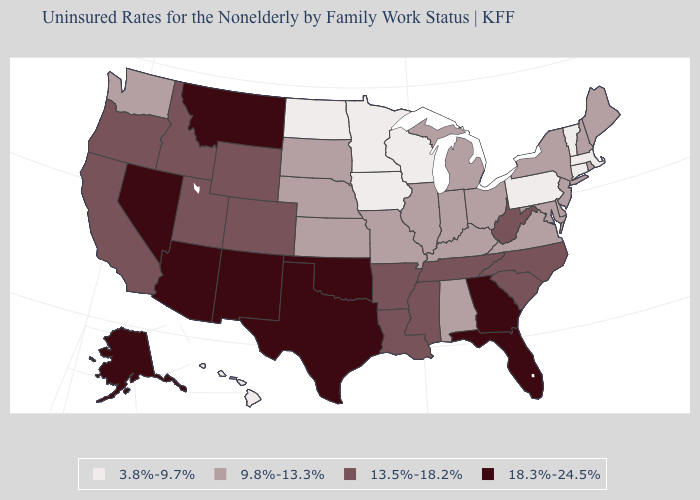Which states have the lowest value in the Northeast?
Concise answer only. Connecticut, Massachusetts, Pennsylvania, Vermont. Name the states that have a value in the range 9.8%-13.3%?
Answer briefly. Alabama, Delaware, Illinois, Indiana, Kansas, Kentucky, Maine, Maryland, Michigan, Missouri, Nebraska, New Hampshire, New Jersey, New York, Ohio, Rhode Island, South Dakota, Virginia, Washington. Name the states that have a value in the range 3.8%-9.7%?
Quick response, please. Connecticut, Hawaii, Iowa, Massachusetts, Minnesota, North Dakota, Pennsylvania, Vermont, Wisconsin. Does the first symbol in the legend represent the smallest category?
Give a very brief answer. Yes. Name the states that have a value in the range 9.8%-13.3%?
Be succinct. Alabama, Delaware, Illinois, Indiana, Kansas, Kentucky, Maine, Maryland, Michigan, Missouri, Nebraska, New Hampshire, New Jersey, New York, Ohio, Rhode Island, South Dakota, Virginia, Washington. Among the states that border North Carolina , does Georgia have the highest value?
Keep it brief. Yes. Among the states that border Virginia , does North Carolina have the lowest value?
Answer briefly. No. Name the states that have a value in the range 13.5%-18.2%?
Answer briefly. Arkansas, California, Colorado, Idaho, Louisiana, Mississippi, North Carolina, Oregon, South Carolina, Tennessee, Utah, West Virginia, Wyoming. Among the states that border Massachusetts , which have the highest value?
Give a very brief answer. New Hampshire, New York, Rhode Island. Does Ohio have a lower value than New Mexico?
Give a very brief answer. Yes. What is the value of Georgia?
Keep it brief. 18.3%-24.5%. What is the value of Idaho?
Keep it brief. 13.5%-18.2%. What is the value of Washington?
Concise answer only. 9.8%-13.3%. Name the states that have a value in the range 3.8%-9.7%?
Be succinct. Connecticut, Hawaii, Iowa, Massachusetts, Minnesota, North Dakota, Pennsylvania, Vermont, Wisconsin. Name the states that have a value in the range 18.3%-24.5%?
Write a very short answer. Alaska, Arizona, Florida, Georgia, Montana, Nevada, New Mexico, Oklahoma, Texas. 